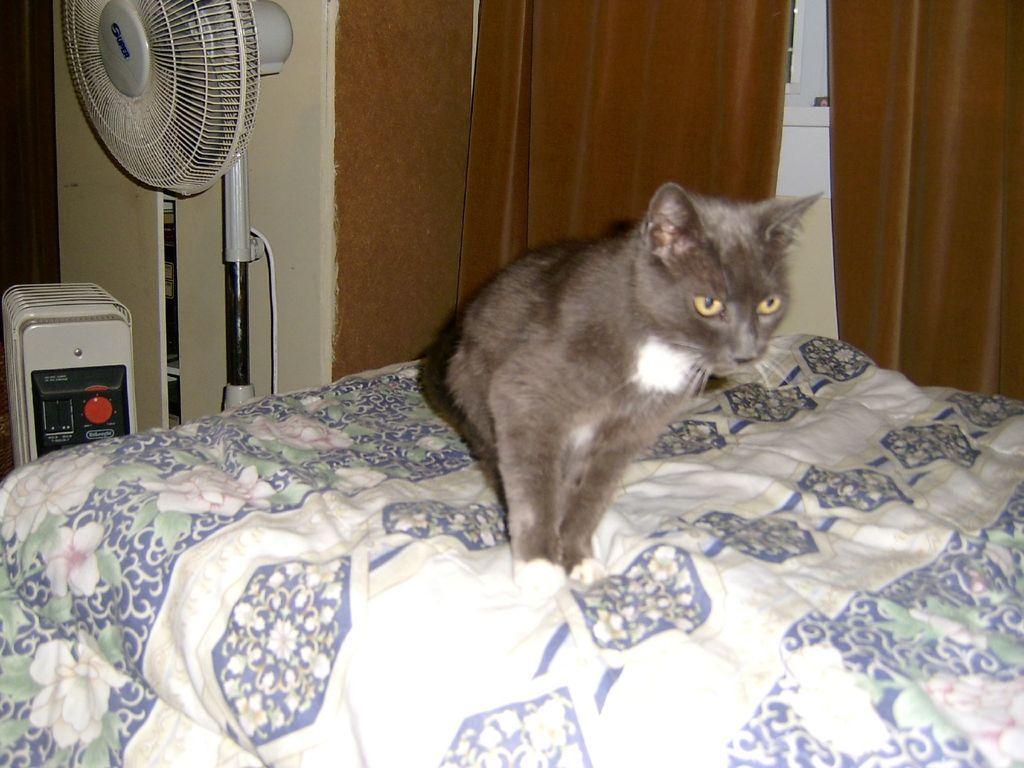In one or two sentences, can you explain what this image depicts? In the foreground of the image we can see a cat on the surface. To the left side of the image we can see a table fan and a device placed on the ground. In the background, we can see cupboard, window and curtains. 